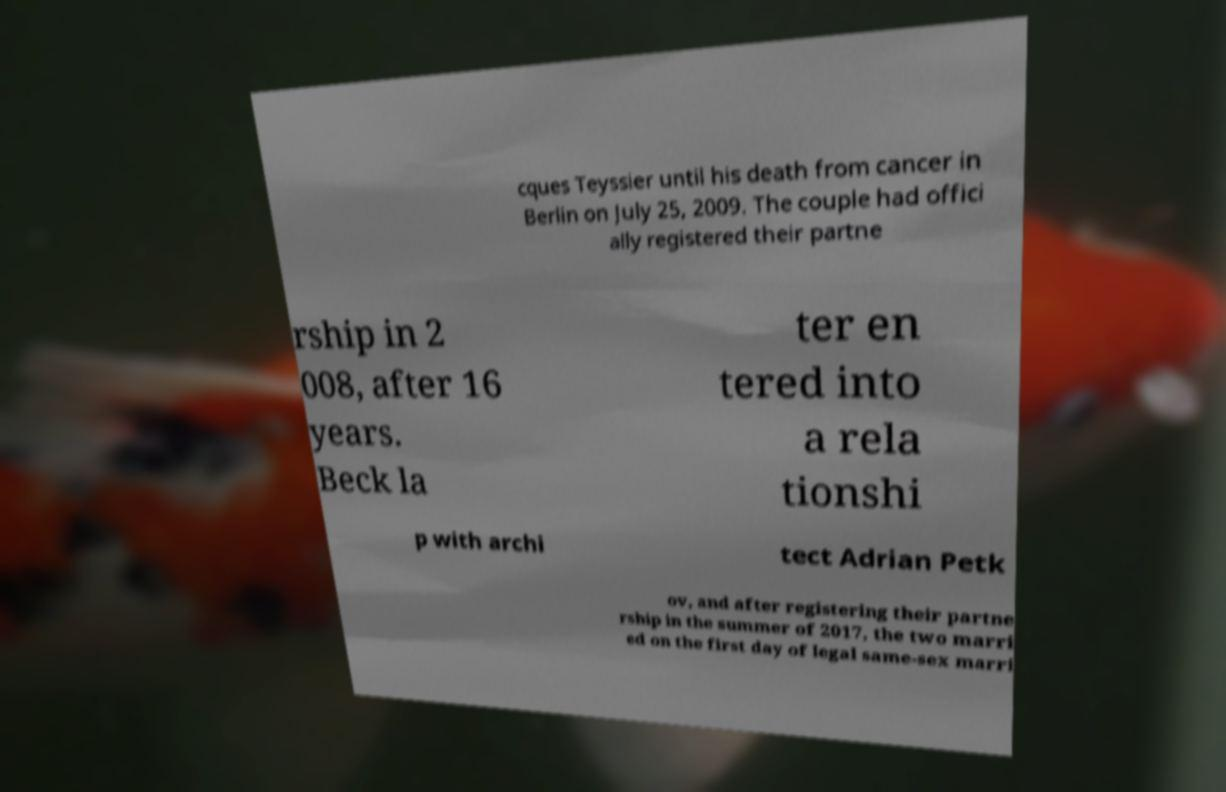Please identify and transcribe the text found in this image. cques Teyssier until his death from cancer in Berlin on July 25, 2009. The couple had offici ally registered their partne rship in 2 008, after 16 years. Beck la ter en tered into a rela tionshi p with archi tect Adrian Petk ov, and after registering their partne rship in the summer of 2017, the two marri ed on the first day of legal same-sex marri 